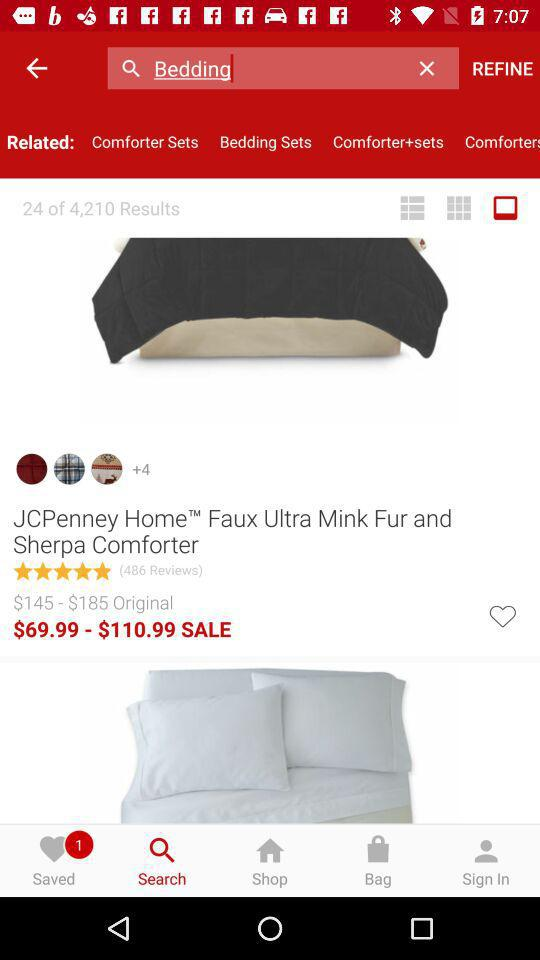What is the original price range of the "JCPenney Home Faux Ultra Mink Fur and Sherpa Comforter"? The original price ranges from $145 to $185. 